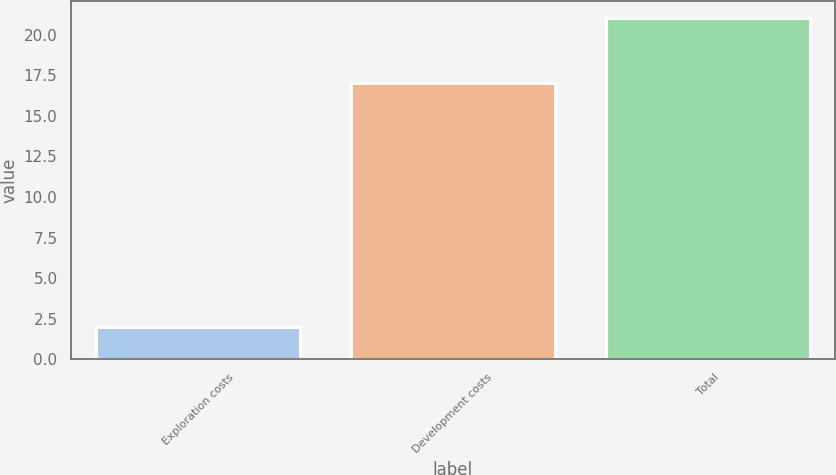Convert chart. <chart><loc_0><loc_0><loc_500><loc_500><bar_chart><fcel>Exploration costs<fcel>Development costs<fcel>Total<nl><fcel>2<fcel>17<fcel>21<nl></chart> 